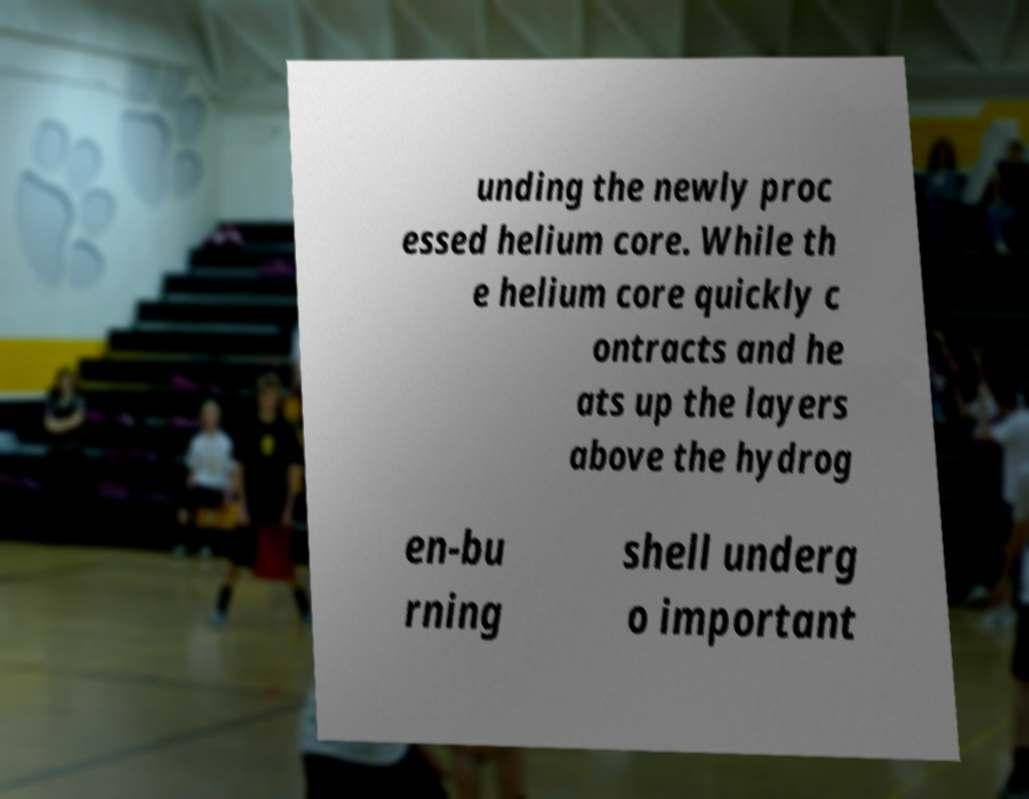Can you read and provide the text displayed in the image?This photo seems to have some interesting text. Can you extract and type it out for me? unding the newly proc essed helium core. While th e helium core quickly c ontracts and he ats up the layers above the hydrog en-bu rning shell underg o important 